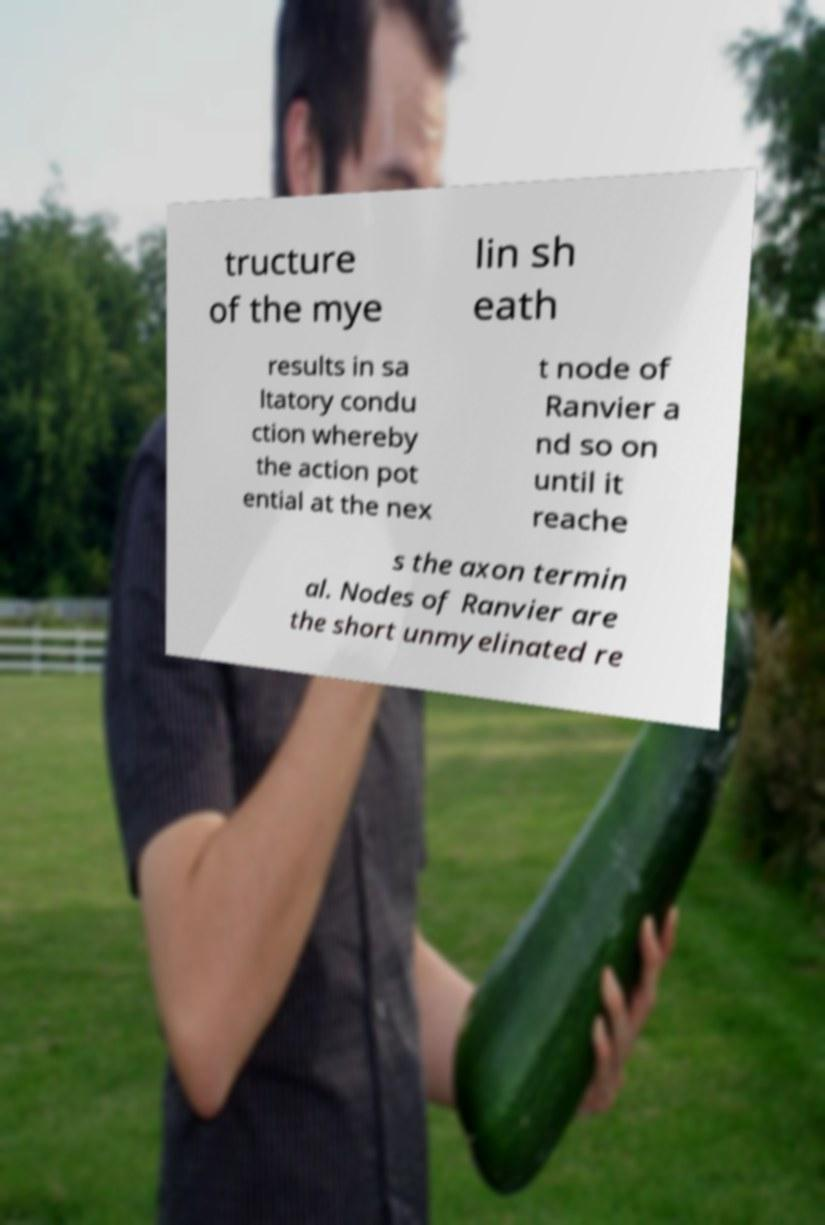For documentation purposes, I need the text within this image transcribed. Could you provide that? tructure of the mye lin sh eath results in sa ltatory condu ction whereby the action pot ential at the nex t node of Ranvier a nd so on until it reache s the axon termin al. Nodes of Ranvier are the short unmyelinated re 